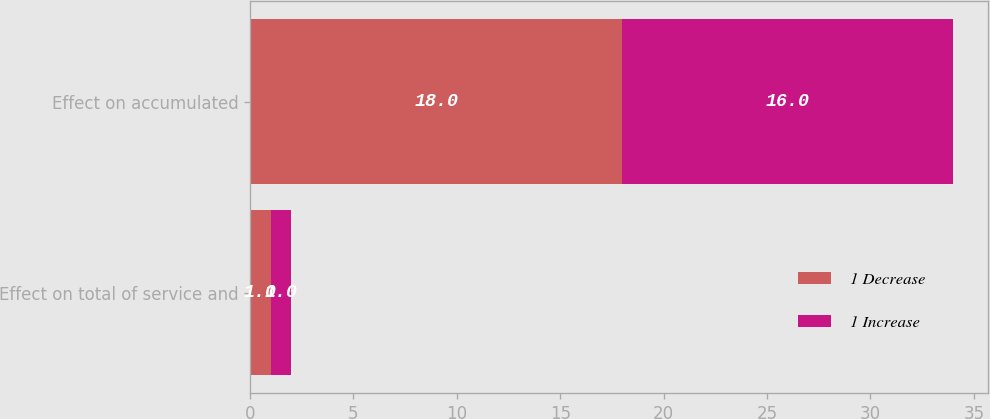Convert chart. <chart><loc_0><loc_0><loc_500><loc_500><stacked_bar_chart><ecel><fcel>Effect on total of service and<fcel>Effect on accumulated<nl><fcel>1 Decrease<fcel>1<fcel>18<nl><fcel>1 Increase<fcel>1<fcel>16<nl></chart> 